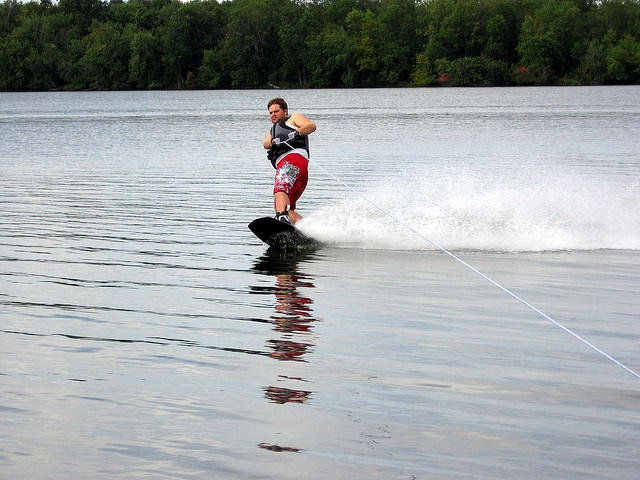Describe the objects in this image and their specific colors. I can see people in lightgray, black, maroon, and brown tones in this image. 